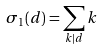Convert formula to latex. <formula><loc_0><loc_0><loc_500><loc_500>\sigma _ { 1 } ( d ) = \sum _ { k | d } k</formula> 